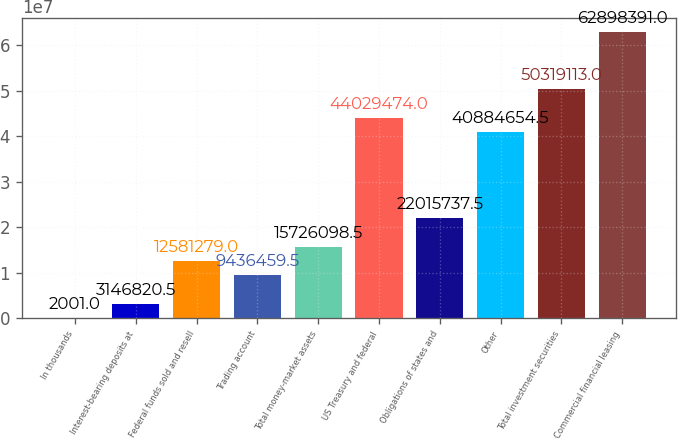<chart> <loc_0><loc_0><loc_500><loc_500><bar_chart><fcel>In thousands<fcel>Interest-bearing deposits at<fcel>Federal funds sold and resell<fcel>Trading account<fcel>Total money-market assets<fcel>US Treasury and federal<fcel>Obligations of states and<fcel>Other<fcel>Total investment securities<fcel>Commercial financial leasing<nl><fcel>2001<fcel>3.14682e+06<fcel>1.25813e+07<fcel>9.43646e+06<fcel>1.57261e+07<fcel>4.40295e+07<fcel>2.20157e+07<fcel>4.08847e+07<fcel>5.03191e+07<fcel>6.28984e+07<nl></chart> 